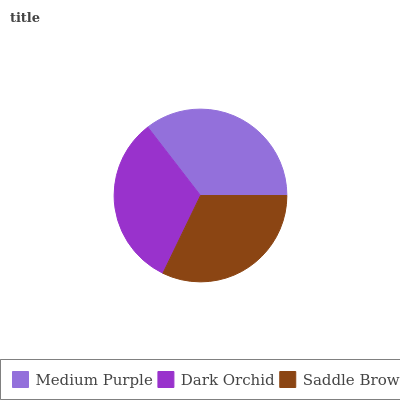Is Saddle Brown the minimum?
Answer yes or no. Yes. Is Medium Purple the maximum?
Answer yes or no. Yes. Is Dark Orchid the minimum?
Answer yes or no. No. Is Dark Orchid the maximum?
Answer yes or no. No. Is Medium Purple greater than Dark Orchid?
Answer yes or no. Yes. Is Dark Orchid less than Medium Purple?
Answer yes or no. Yes. Is Dark Orchid greater than Medium Purple?
Answer yes or no. No. Is Medium Purple less than Dark Orchid?
Answer yes or no. No. Is Dark Orchid the high median?
Answer yes or no. Yes. Is Dark Orchid the low median?
Answer yes or no. Yes. Is Saddle Brown the high median?
Answer yes or no. No. Is Saddle Brown the low median?
Answer yes or no. No. 